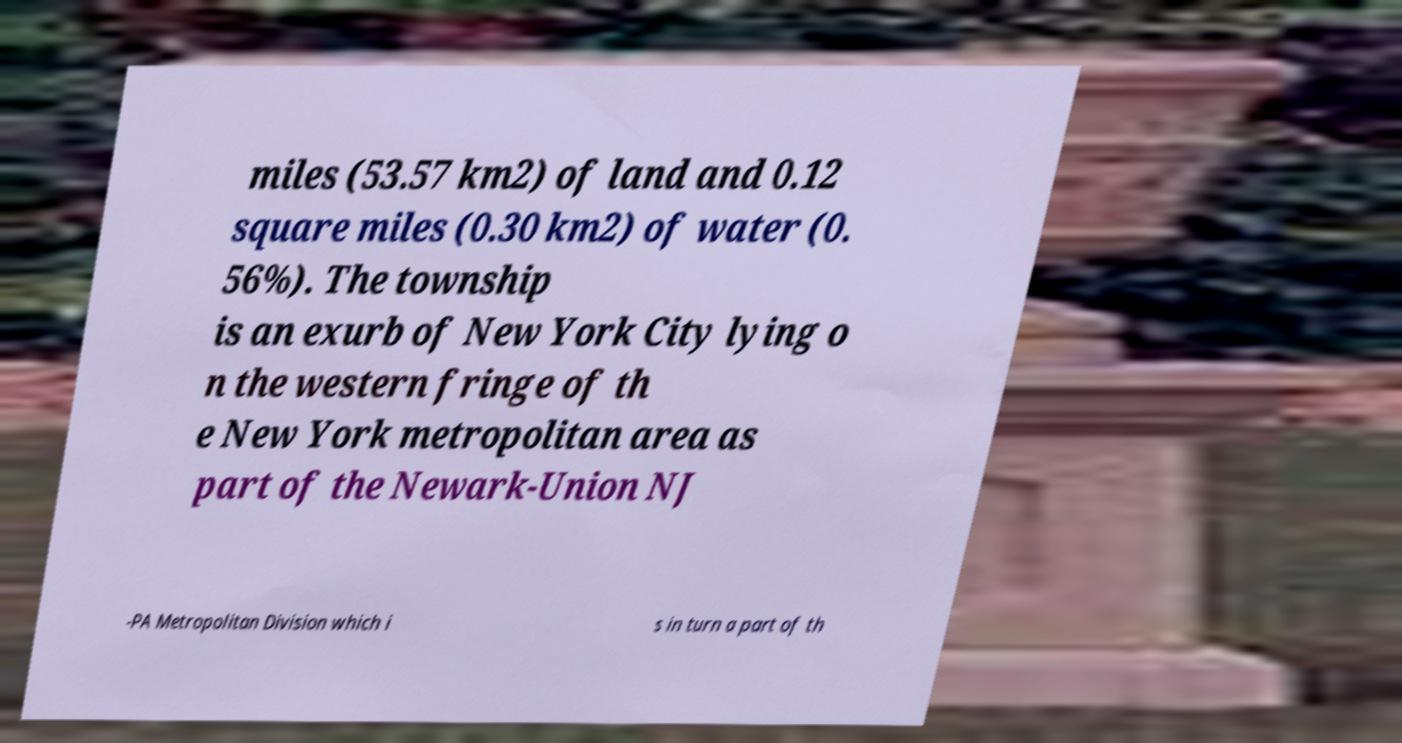Can you accurately transcribe the text from the provided image for me? miles (53.57 km2) of land and 0.12 square miles (0.30 km2) of water (0. 56%). The township is an exurb of New York City lying o n the western fringe of th e New York metropolitan area as part of the Newark-Union NJ -PA Metropolitan Division which i s in turn a part of th 